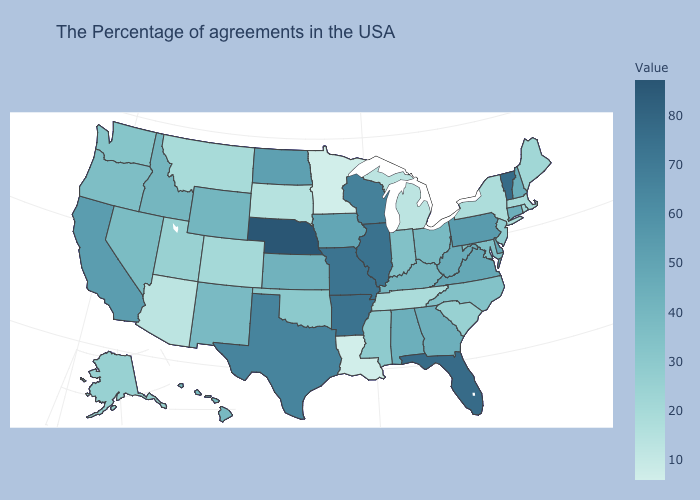Does California have the highest value in the West?
Short answer required. Yes. Which states have the highest value in the USA?
Be succinct. Nebraska. Among the states that border Georgia , which have the lowest value?
Write a very short answer. Tennessee. Which states have the lowest value in the MidWest?
Give a very brief answer. Minnesota. 